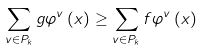<formula> <loc_0><loc_0><loc_500><loc_500>\sum _ { v \in P _ { k } } g \varphi ^ { v } \left ( x \right ) \geq \sum _ { v \in P _ { k } } f \varphi ^ { v } \left ( x \right )</formula> 